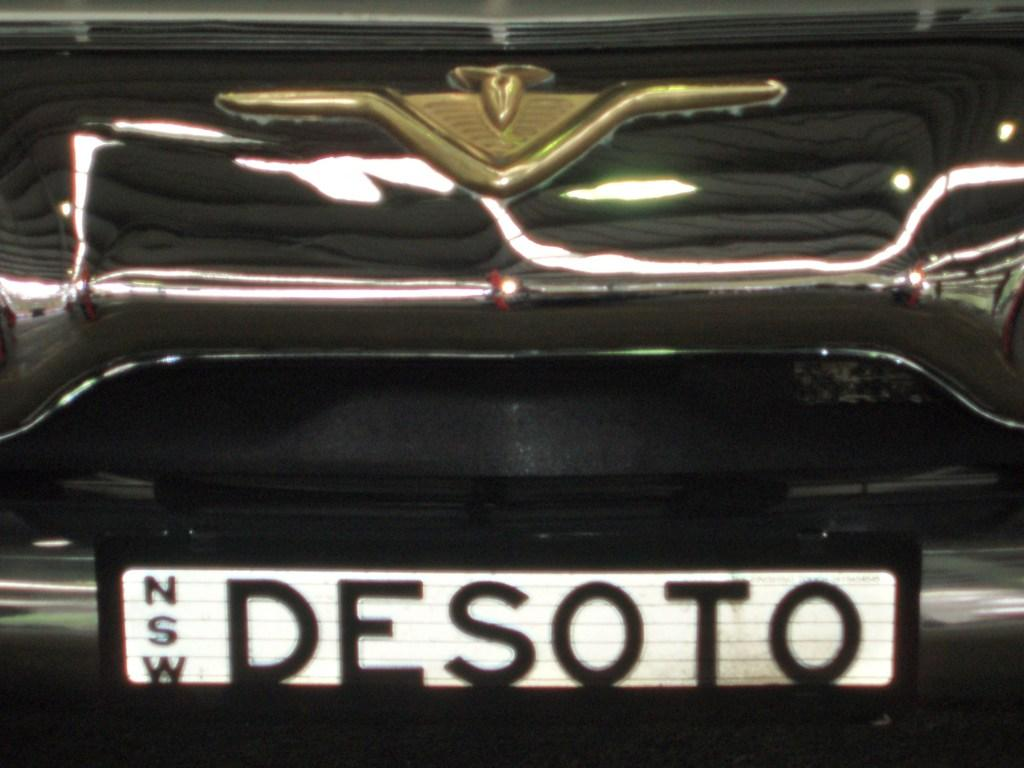<image>
Share a concise interpretation of the image provided. the word desoto is on the front of a white background 